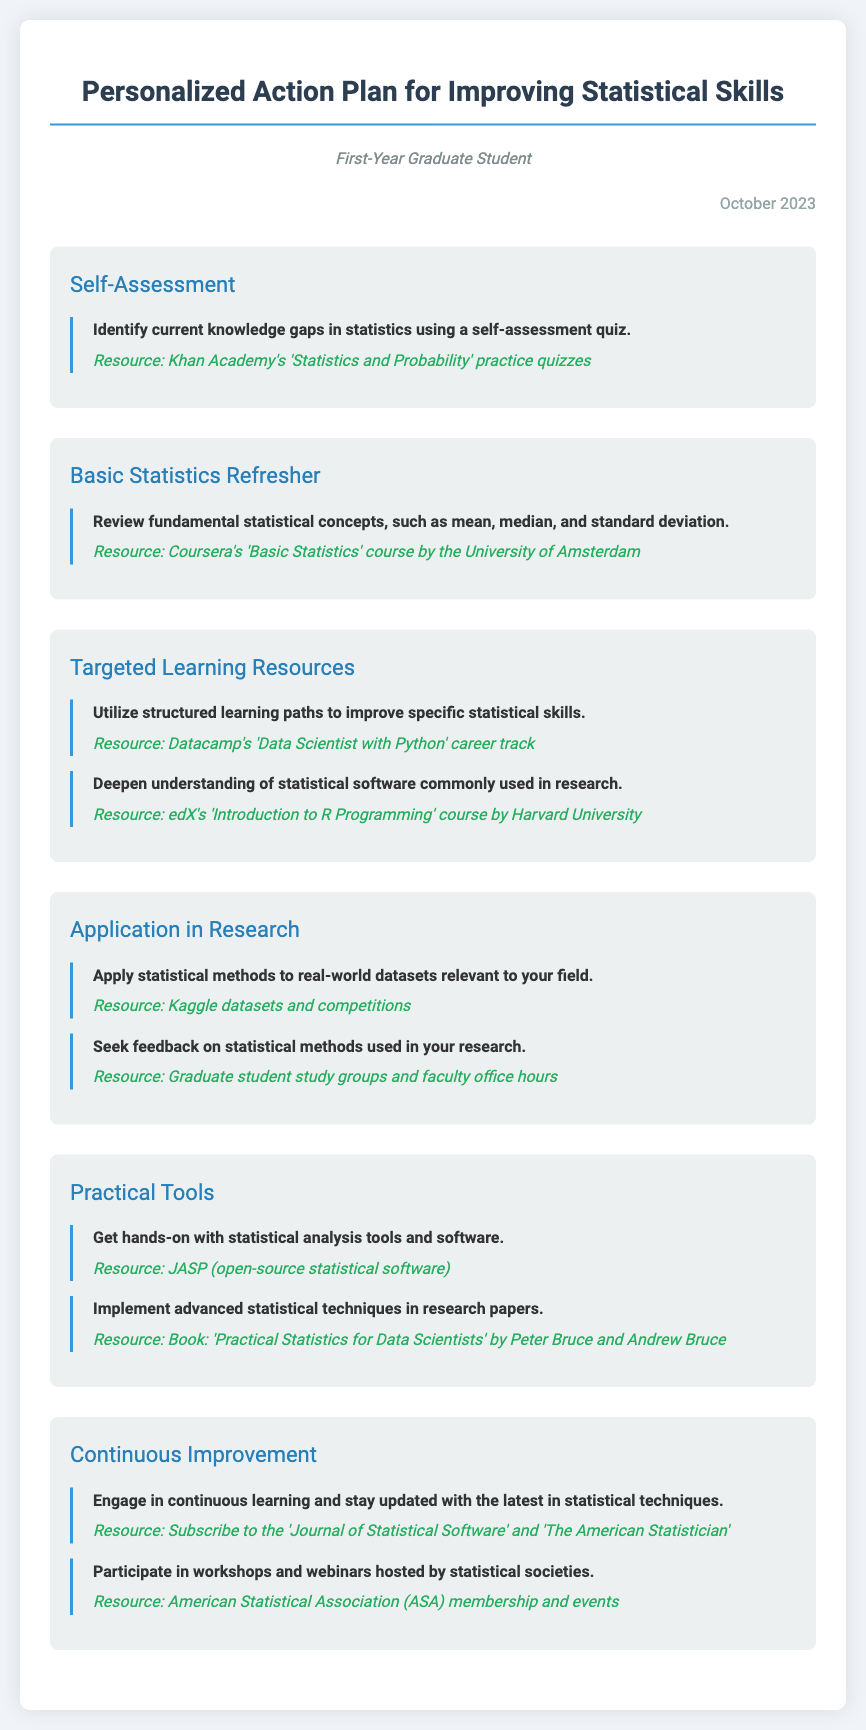What is the title of the document? The title of the document is displayed prominently at the top of the rendered document.
Answer: Personalized Action Plan for Improving Statistical Skills What resource is recommended for self-assessment? The document contains a specific resource for assessing current knowledge gaps.
Answer: Khan Academy's 'Statistics and Probability' practice quizzes What course is suggested for a basic statistics refresher? The document provides a recommended course for reviewing fundamental statistical concepts.
Answer: Coursera's 'Basic Statistics' course by the University of Amsterdam Which software is suggested for hands-on statistical analysis? The document lists a statistical analysis tool that is open-source.
Answer: JASP What is one of the continuous improvement resources mentioned? The document includes resources for staying updated with statistical techniques.
Answer: Journal of Statistical Software How many sections are there in the document? By counting the sections listed in the document, one can determine the total number.
Answer: Six 